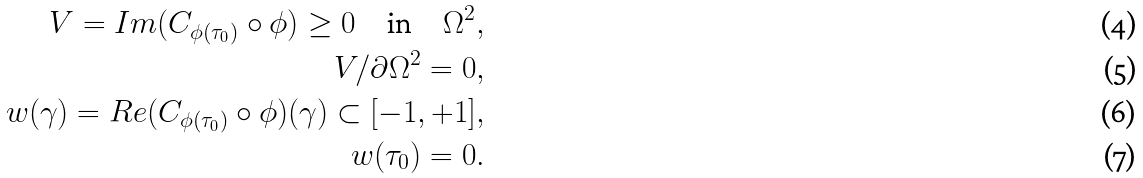Convert formula to latex. <formula><loc_0><loc_0><loc_500><loc_500>V = I m ( C _ { \phi ( \tau _ { 0 } ) } \circ \phi ) \geq 0 \quad \text {in} \quad \Omega ^ { 2 } , \\ V / \partial \Omega ^ { 2 } = 0 , \\ w ( \gamma ) = R e ( C _ { \phi ( \tau _ { 0 } ) } \circ \phi ) ( \gamma ) \subset [ - 1 , + 1 ] , \\ w ( \tau _ { 0 } ) = 0 .</formula> 